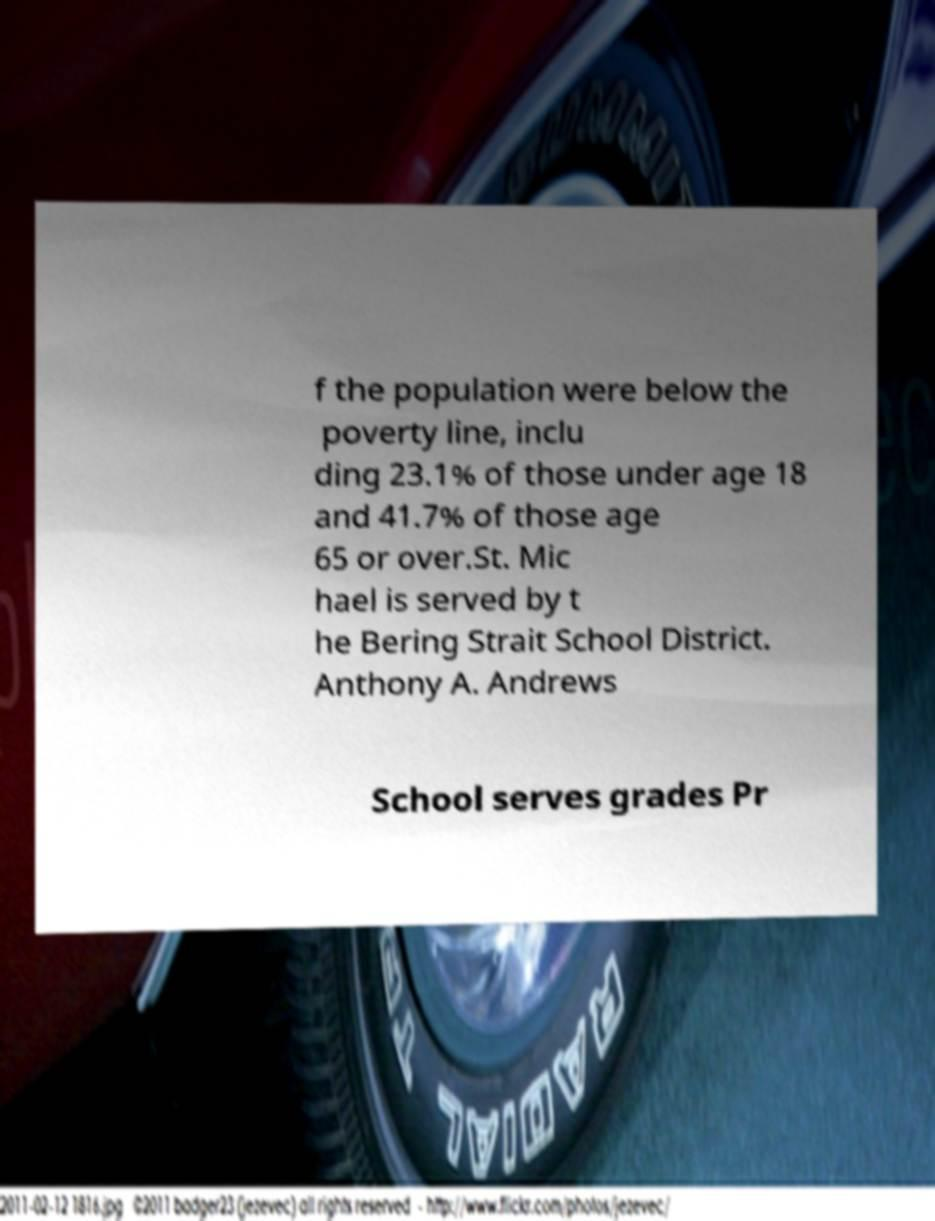Please identify and transcribe the text found in this image. f the population were below the poverty line, inclu ding 23.1% of those under age 18 and 41.7% of those age 65 or over.St. Mic hael is served by t he Bering Strait School District. Anthony A. Andrews School serves grades Pr 